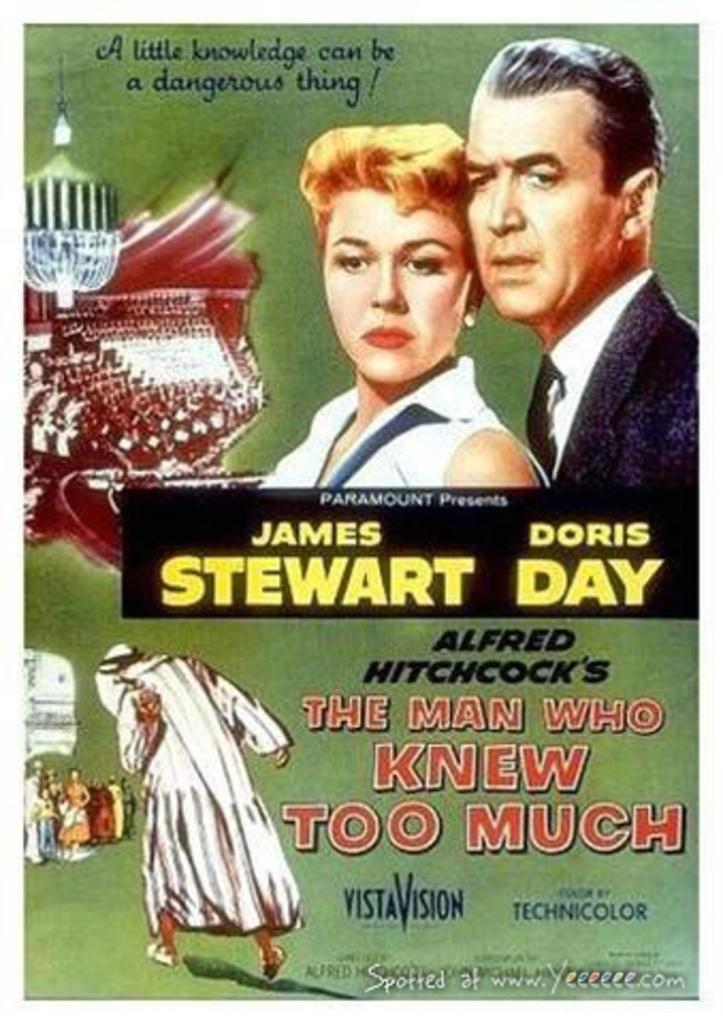What is present in the image that contains information or a message? There is a poster in the image that contains information or a message. What type of content can be found on the poster? The poster contains text and images of persons. Can you see a tent in the image? There is no tent present in the image. What type of animal is depicted in the image? The poster in the image does not depict any animals; it contains text and images of persons. 